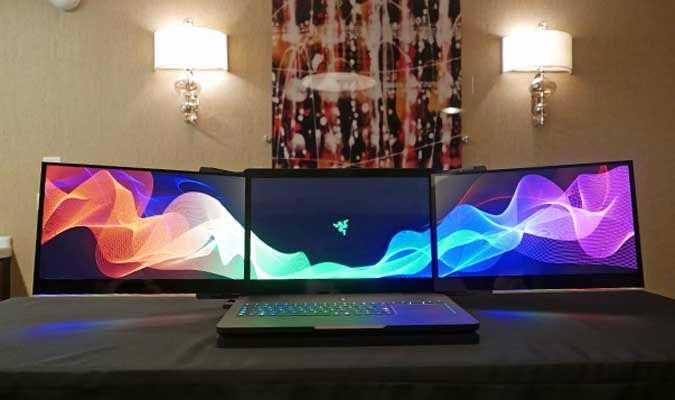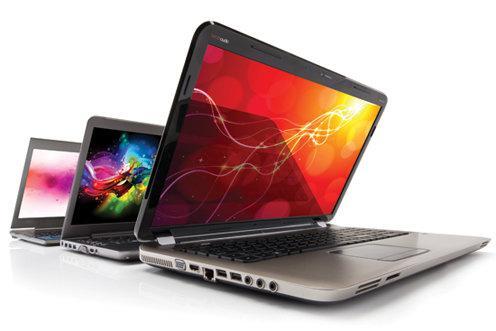The first image is the image on the left, the second image is the image on the right. Assess this claim about the two images: "An image shows a back-to-front row of three keyboards with opened screens displaying various bright colors.". Correct or not? Answer yes or no. Yes. 